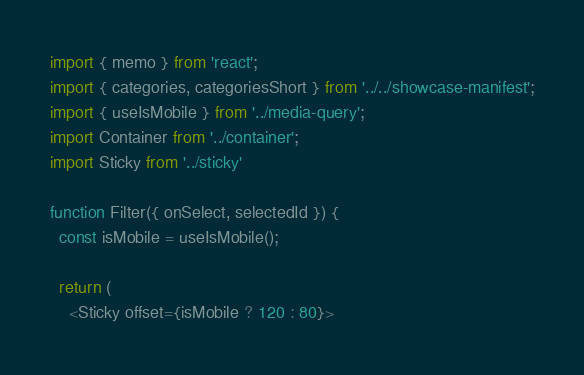<code> <loc_0><loc_0><loc_500><loc_500><_JavaScript_>import { memo } from 'react';
import { categories, categoriesShort } from '../../showcase-manifest';
import { useIsMobile } from '../media-query';
import Container from '../container';
import Sticky from '../sticky'

function Filter({ onSelect, selectedId }) {
  const isMobile = useIsMobile();

  return (
    <Sticky offset={isMobile ? 120 : 80}></code> 